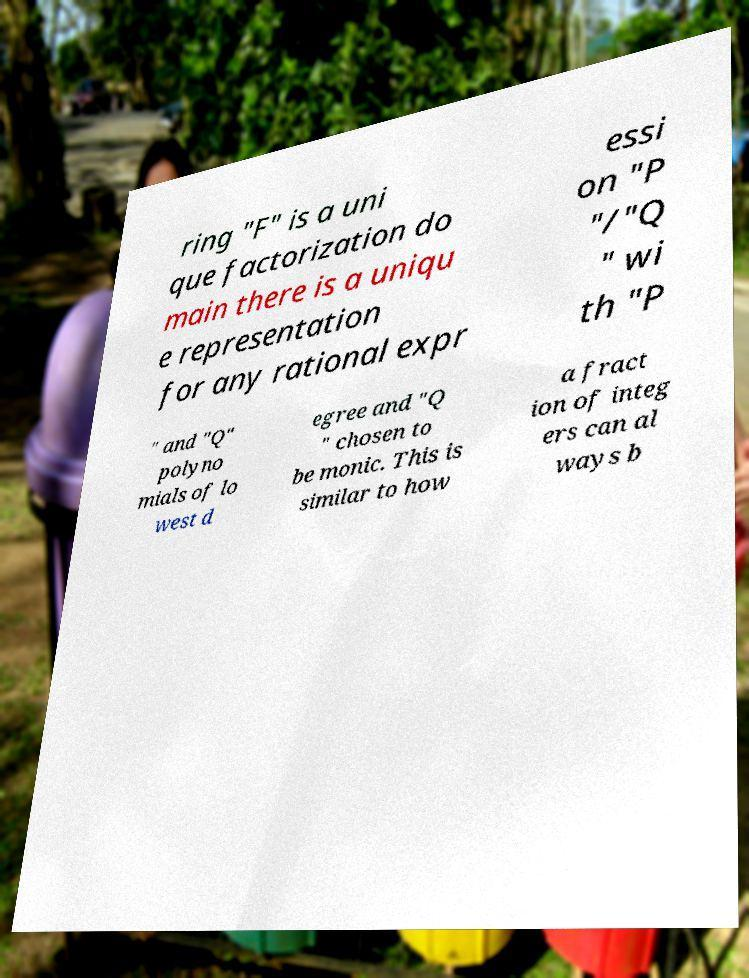Can you read and provide the text displayed in the image?This photo seems to have some interesting text. Can you extract and type it out for me? ring "F" is a uni que factorization do main there is a uniqu e representation for any rational expr essi on "P "/"Q " wi th "P " and "Q" polyno mials of lo west d egree and "Q " chosen to be monic. This is similar to how a fract ion of integ ers can al ways b 